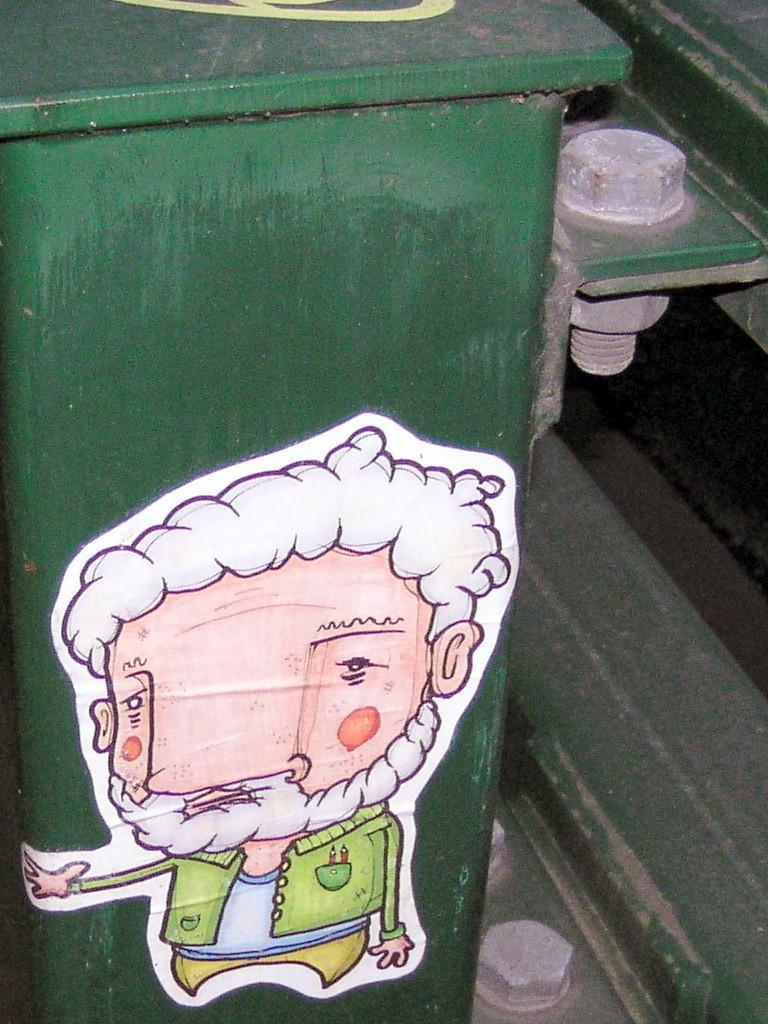Could you give a brief overview of what you see in this image? In this picture, we see a green color table on which sticker is placed. On the right side, we see iron bolts. In the background, it is green in color. 